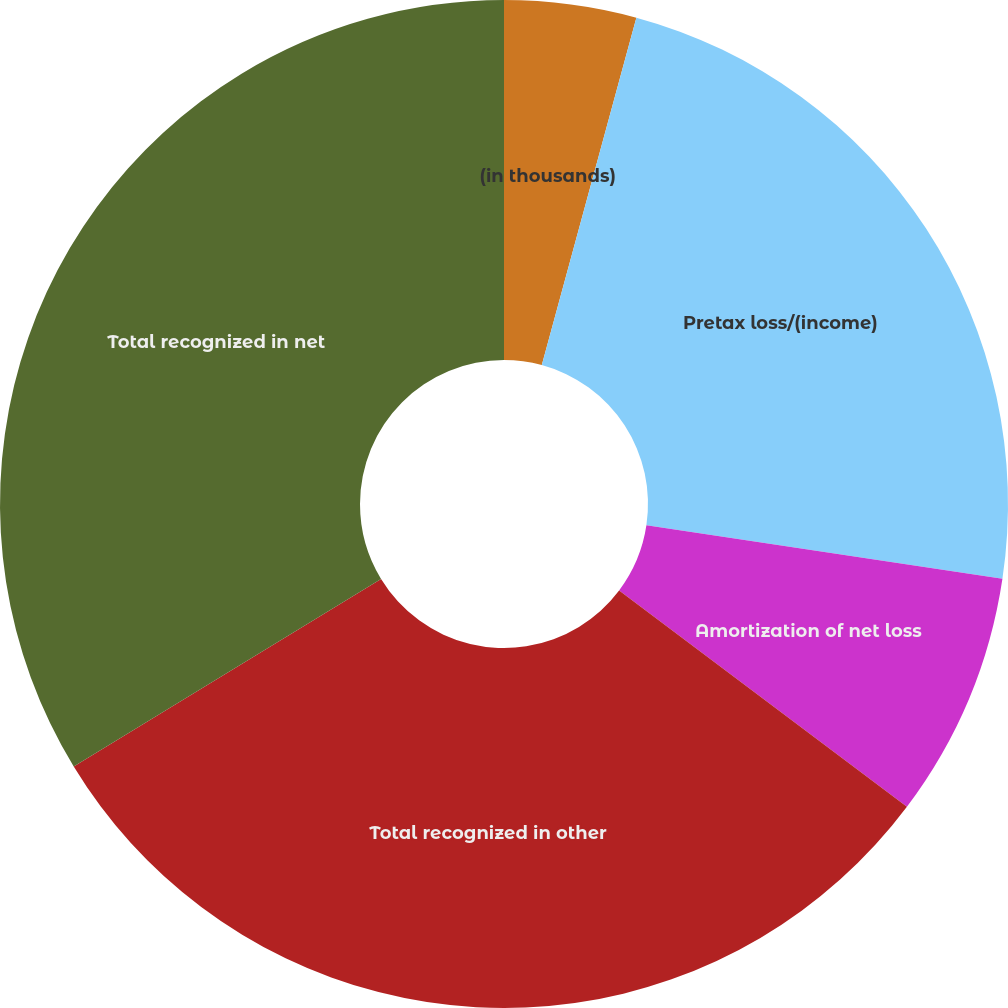<chart> <loc_0><loc_0><loc_500><loc_500><pie_chart><fcel>(in thousands)<fcel>Pretax loss/(income)<fcel>Amortization of net loss<fcel>Total recognized in other<fcel>Total recognized in net<nl><fcel>4.23%<fcel>23.14%<fcel>7.89%<fcel>31.03%<fcel>33.72%<nl></chart> 